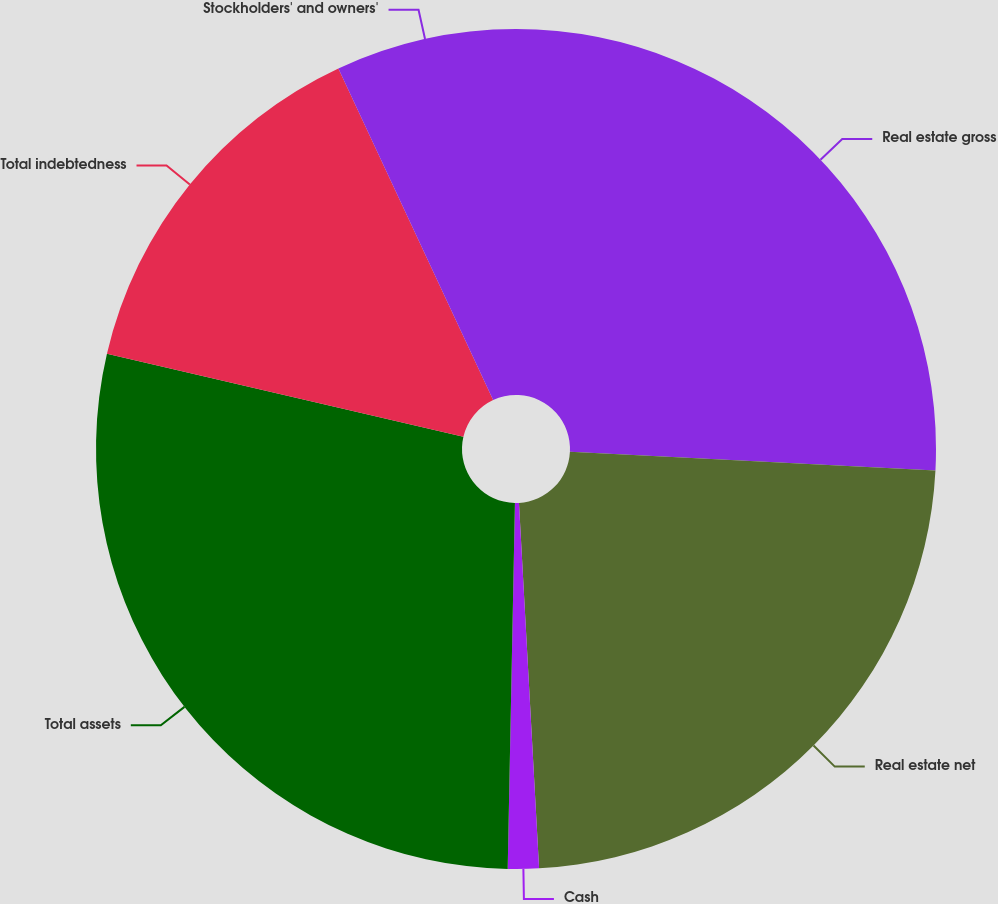Convert chart. <chart><loc_0><loc_0><loc_500><loc_500><pie_chart><fcel>Real estate gross<fcel>Real estate net<fcel>Cash<fcel>Total assets<fcel>Total indebtedness<fcel>Stockholders' and owners'<nl><fcel>25.82%<fcel>23.31%<fcel>1.19%<fcel>28.33%<fcel>14.41%<fcel>6.95%<nl></chart> 